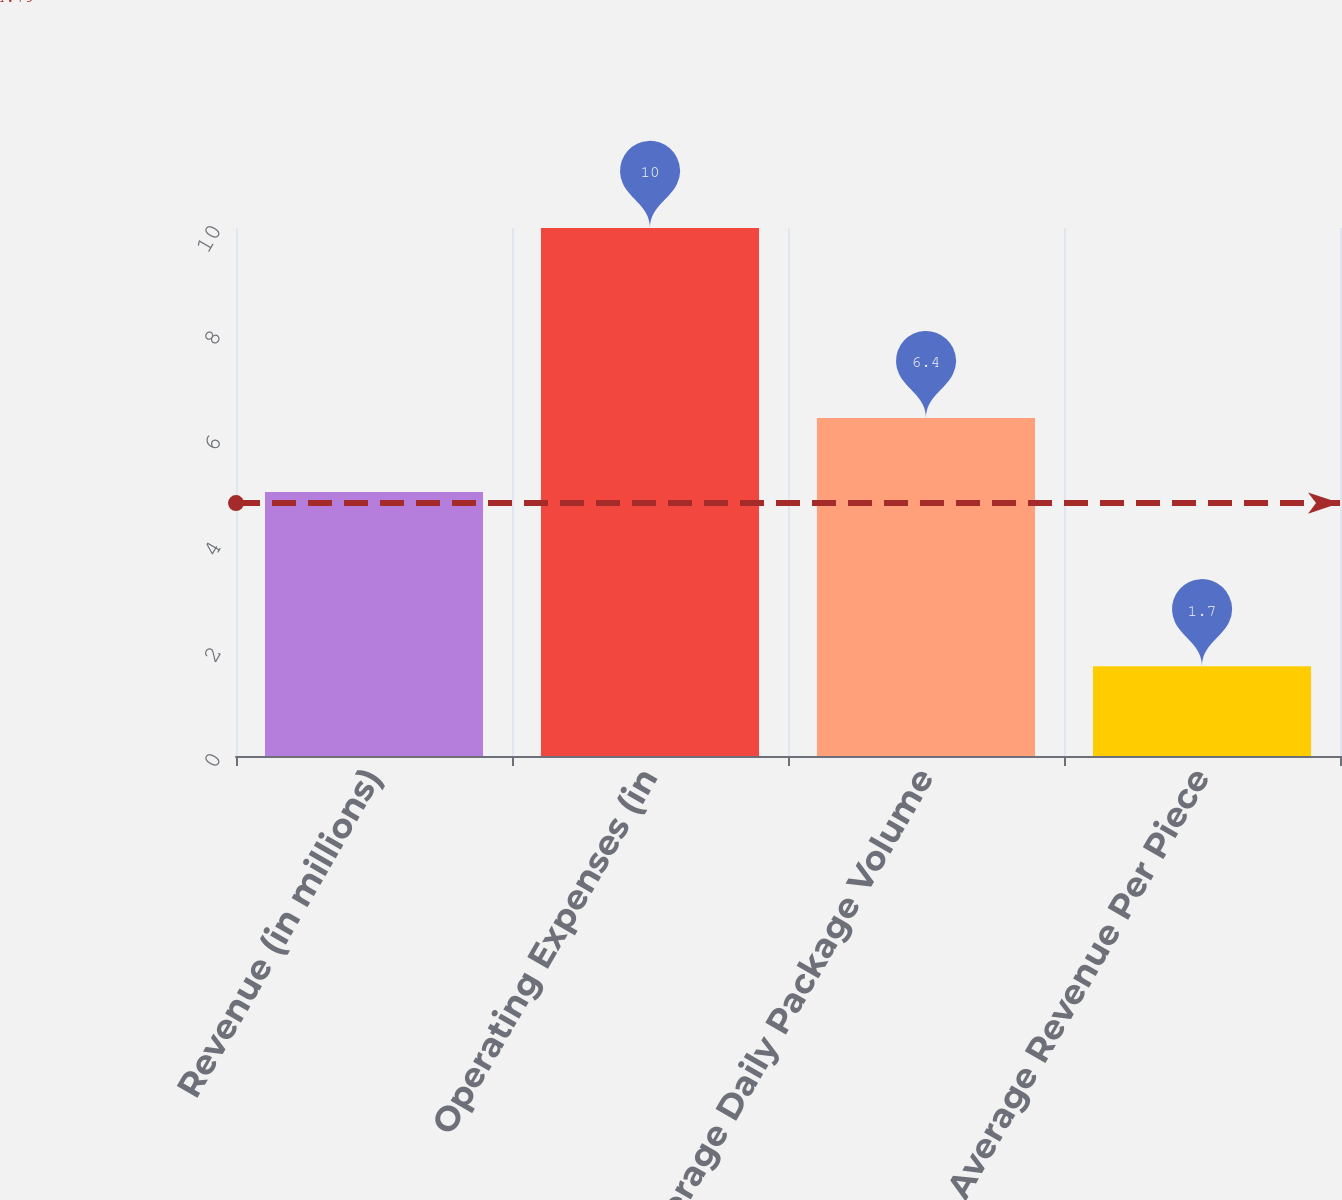<chart> <loc_0><loc_0><loc_500><loc_500><bar_chart><fcel>Revenue (in millions)<fcel>Operating Expenses (in<fcel>Average Daily Package Volume<fcel>Average Revenue Per Piece<nl><fcel>5<fcel>10<fcel>6.4<fcel>1.7<nl></chart> 